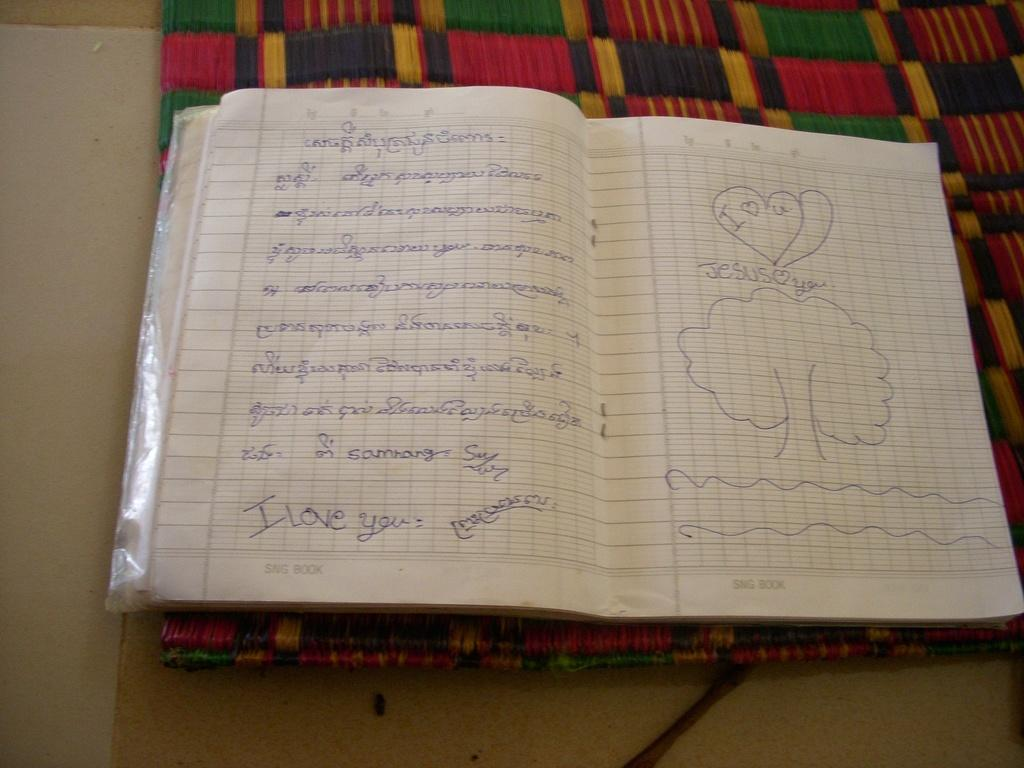<image>
Offer a succinct explanation of the picture presented. Notebook with I love you and Jesus love you wrote on the pages. 